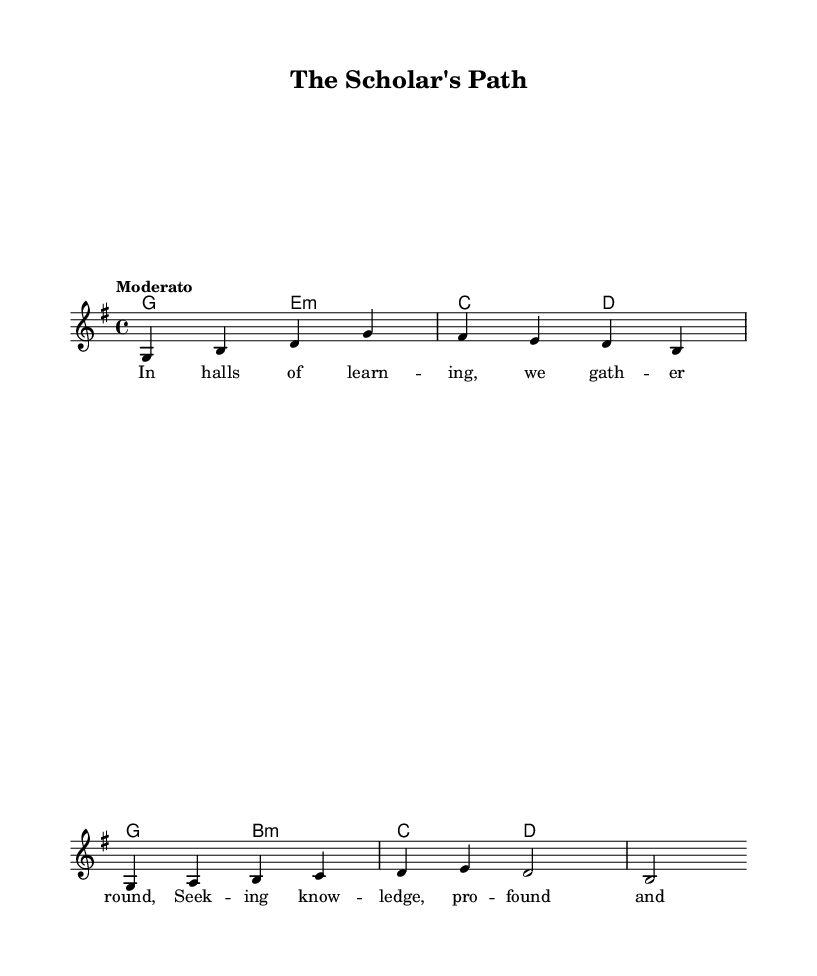What is the key signature of this music? The key signature indicated at the beginning of the sheet music is G major, which has one sharp (F#).
Answer: G major What is the time signature of this piece? The time signature shown at the beginning of the sheet music is 4/4, meaning there are four beats in each measure and the quarter note gets one beat.
Answer: 4/4 What tempo marking is given for this music? The tempo marking is indicated as "Moderato," which suggests a moderate speed for the piece.
Answer: Moderato How many measures are in the melody? By counting the measures in the melody section, there are four measures present in this excerpt.
Answer: Four What chords are played in the first two measures? The chords indicated in the first two measures are G major and E minor, showing the harmonic foundation for the melody in this section.
Answer: G major, E minor What do the lyrics suggest about the theme of the song? The lyrics reference themes of learning and the pursuit of knowledge, emphasizing academic life and intellectual engagement.
Answer: Academic life and knowledge Which voice is responsible for the melody in this score? The melody is assigned to a voice labeled "melody" in the score, indicating it is distinct from other harmonic or accompaniment parts.
Answer: Melody 